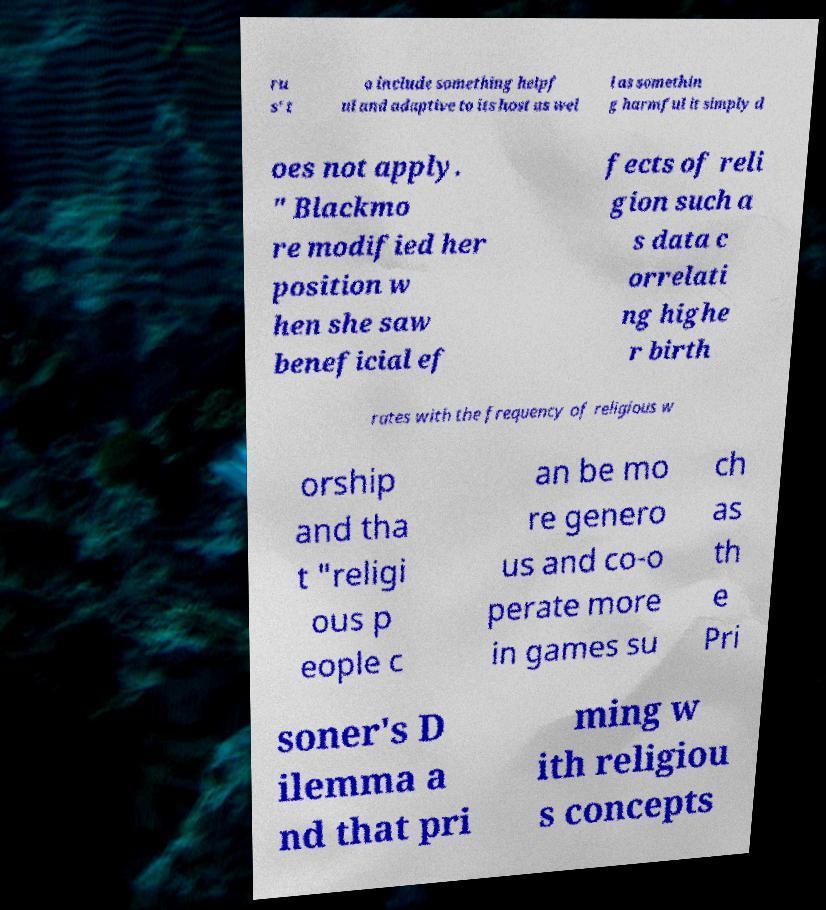Please identify and transcribe the text found in this image. ru s' t o include something helpf ul and adaptive to its host as wel l as somethin g harmful it simply d oes not apply. " Blackmo re modified her position w hen she saw beneficial ef fects of reli gion such a s data c orrelati ng highe r birth rates with the frequency of religious w orship and tha t "religi ous p eople c an be mo re genero us and co-o perate more in games su ch as th e Pri soner's D ilemma a nd that pri ming w ith religiou s concepts 